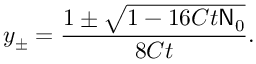<formula> <loc_0><loc_0><loc_500><loc_500>y _ { \pm } = \frac { 1 \pm \sqrt { 1 - 1 6 C t N _ { 0 } } } { 8 C t } .</formula> 